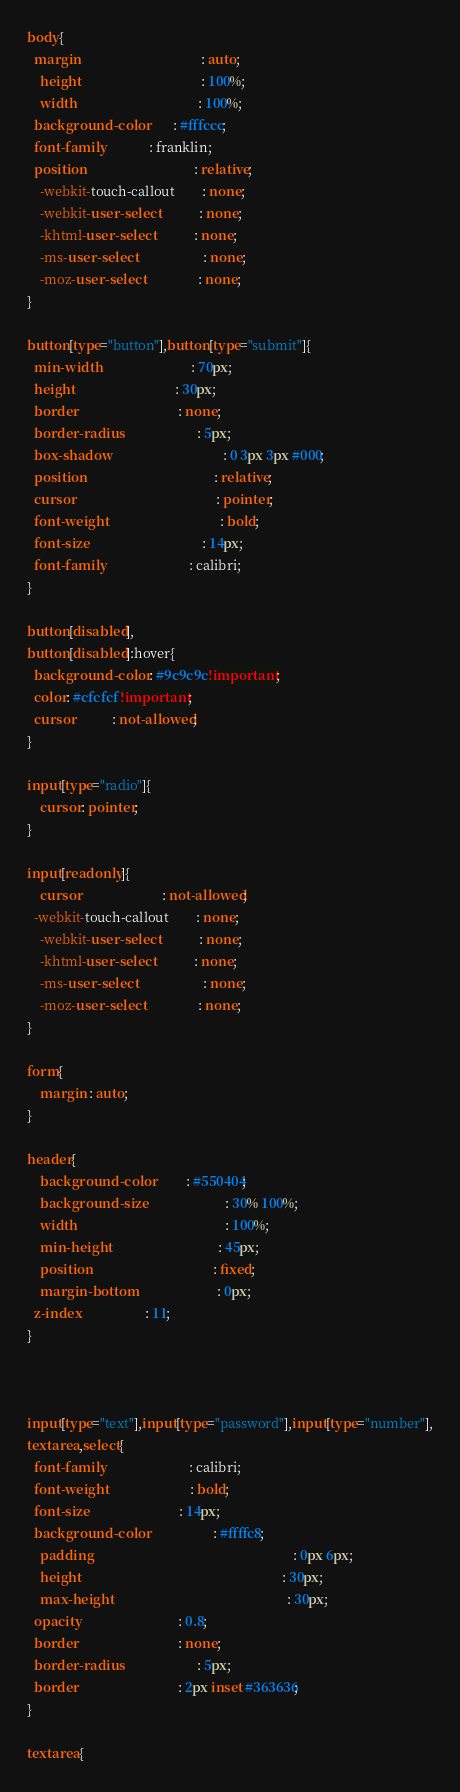<code> <loc_0><loc_0><loc_500><loc_500><_CSS_>body{
  margin									: auto;
	height 									: 100%;
	width 									: 100%;
  background-color        : #fffccc;
  font-family             : franklin;
  position 								: relative;
	-webkit-touch-callout		: none;
	-webkit-user-select			: none;
	-khtml-user-select			: none;
	-ms-user-select					: none;
	-moz-user-select				: none;
}

button[type="button"],button[type="submit"]{
  min-width                           : 70px;
  height                              : 30px;
  border                              : none;
  border-radius                       : 5px;
  box-shadow				                  : 0 3px 3px #000;
  position 					                  : relative;
  cursor 						                  : pointer;
  font-weight				                  : bold;
  font-size 				                  : 14px;
  font-family                         : calibri;
}

button[disabled],
button[disabled]:hover{
  background-color : #9c9c9c !important;
  color: #cfcfcf !important;
  cursor           : not-allowed;
}

input[type="radio"]{
	cursor: pointer;
}

input[readonly]{
	cursor 						: not-allowed;
  -webkit-touch-callout		: none;
	-webkit-user-select			: none;
	-khtml-user-select			: none;
	-ms-user-select					: none;
	-moz-user-select				: none;
}

form{
	margin : auto;
}

header{
	background-color          : #550404;
	background-size						: 30% 100%;
	width											: 100%;
	min-height								: 45px;
	position									: fixed;
	margin-bottom 						: 0px;
  z-index                   : 11;
}



input[type="text"],input[type="password"],input[type="number"],
textarea,select{
  font-family                         : calibri;
  font-weight                         : bold;
  font-size                           : 14px;
  background-color                    : #ffffc8;
	padding															: 0px 6px;
	height															: 30px;
	max-height													: 30px;
  opacity                             : 0.8;
  border                              : none;
  border-radius                       : 5px;
  border                              : 2px inset #363636;
}

textarea{</code> 